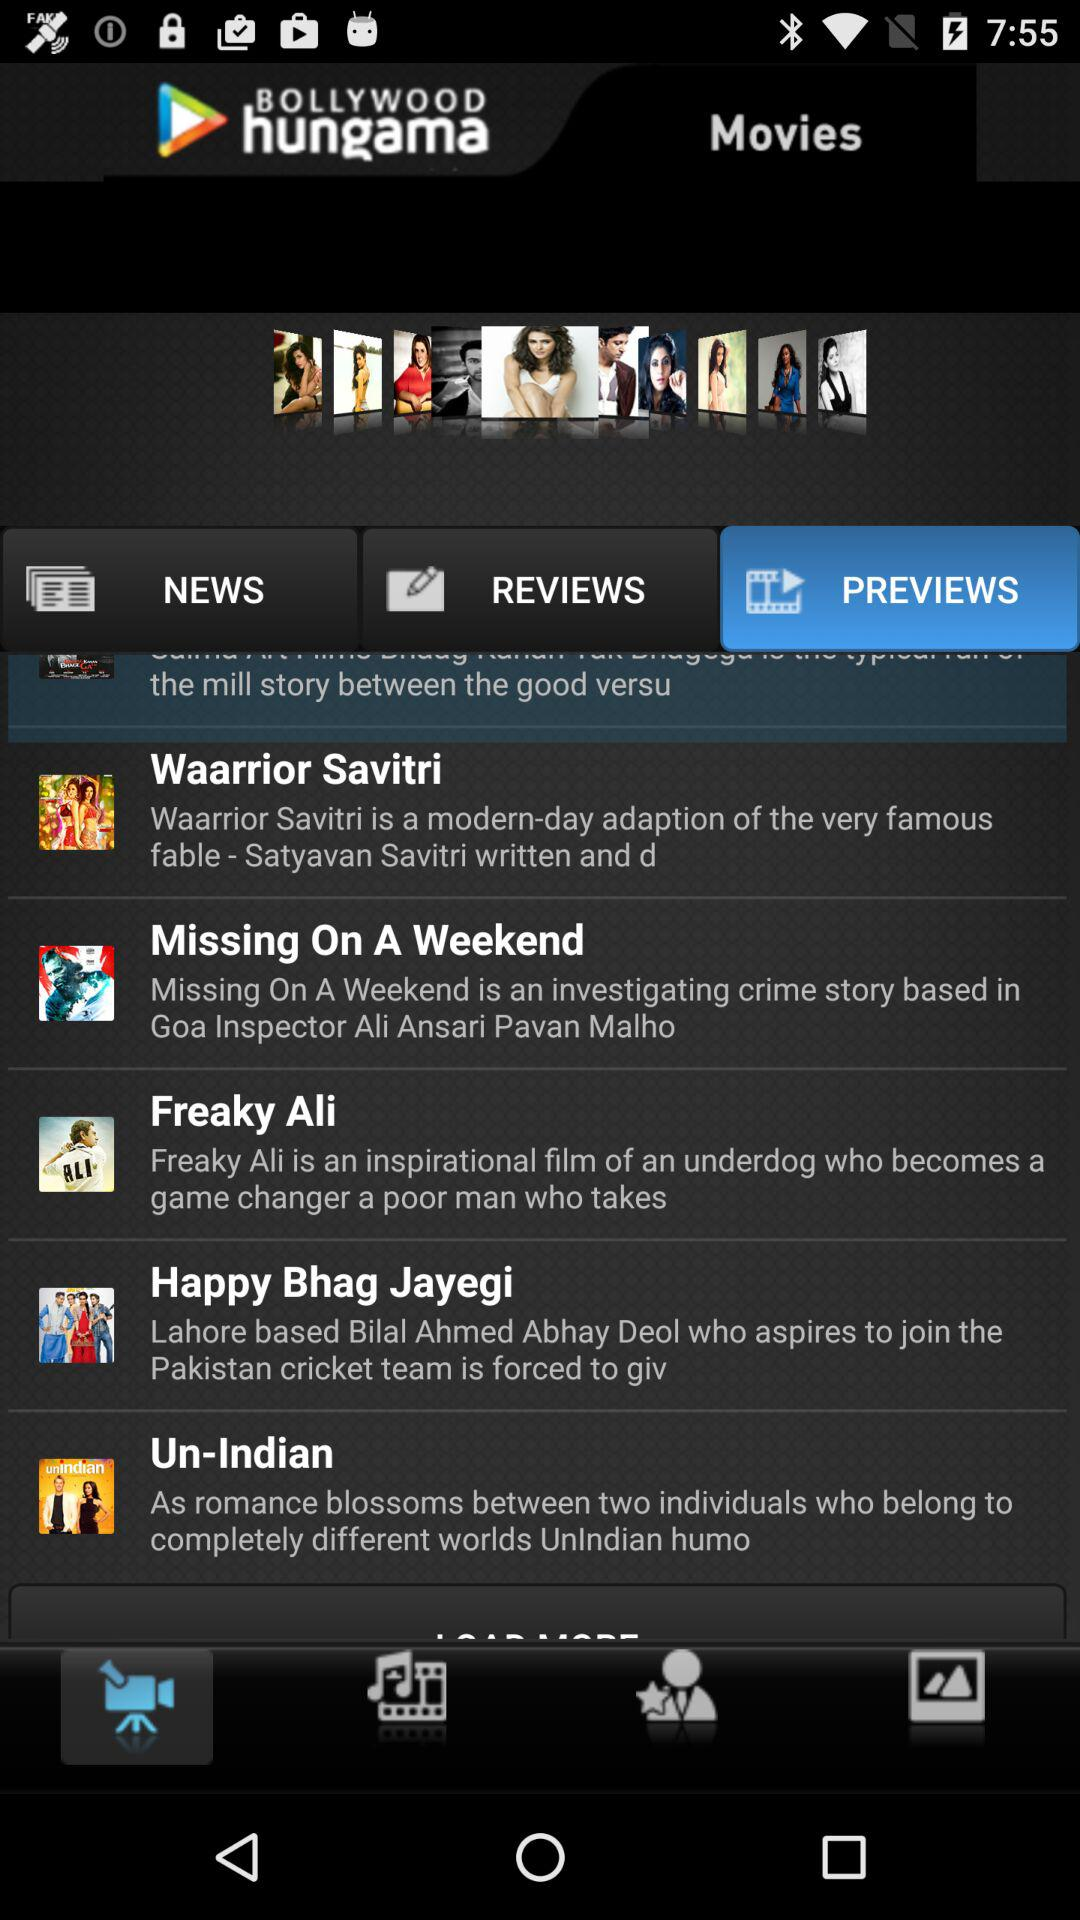What movies are being shown in preview? The movies being shown in preview are : "Waarrior Savitri", "Missing On A Weekend", " Freaky Ali", "Happy Bhag Jayegi", and " Un-Indian". 